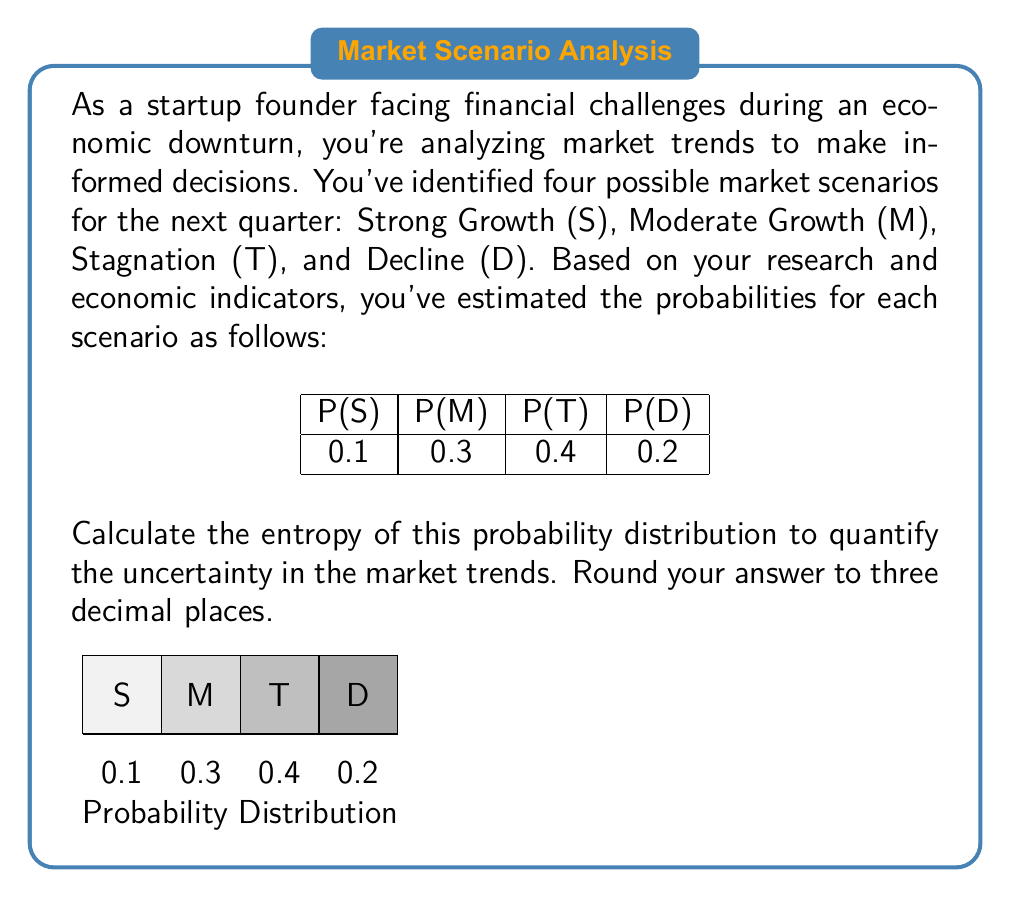Provide a solution to this math problem. To calculate the entropy of a probability distribution, we use the formula:

$$H = -\sum_{i=1}^{n} p_i \log_2(p_i)$$

Where $p_i$ is the probability of each outcome, and $n$ is the number of possible outcomes.

Let's calculate each term:

1) For S: $-0.1 \log_2(0.1)$
   $= -0.1 \times (-3.3219) = 0.33219$

2) For M: $-0.3 \log_2(0.3)$
   $= -0.3 \times (-1.7370) = 0.52110$

3) For T: $-0.4 \log_2(0.4)$
   $= -0.4 \times (-1.3219) = 0.52876$

4) For D: $-0.2 \log_2(0.2)$
   $= -0.2 \times (-2.3219) = 0.46438$

Now, we sum up all these terms:

$H = 0.33219 + 0.52110 + 0.52876 + 0.46438 = 1.84643$

Rounding to three decimal places, we get 1.846.

This entropy value quantifies the uncertainty in the market trends. A higher entropy indicates more uncertainty, which is relevant for a startup founder trying to navigate an economic downturn.
Answer: 1.846 bits 